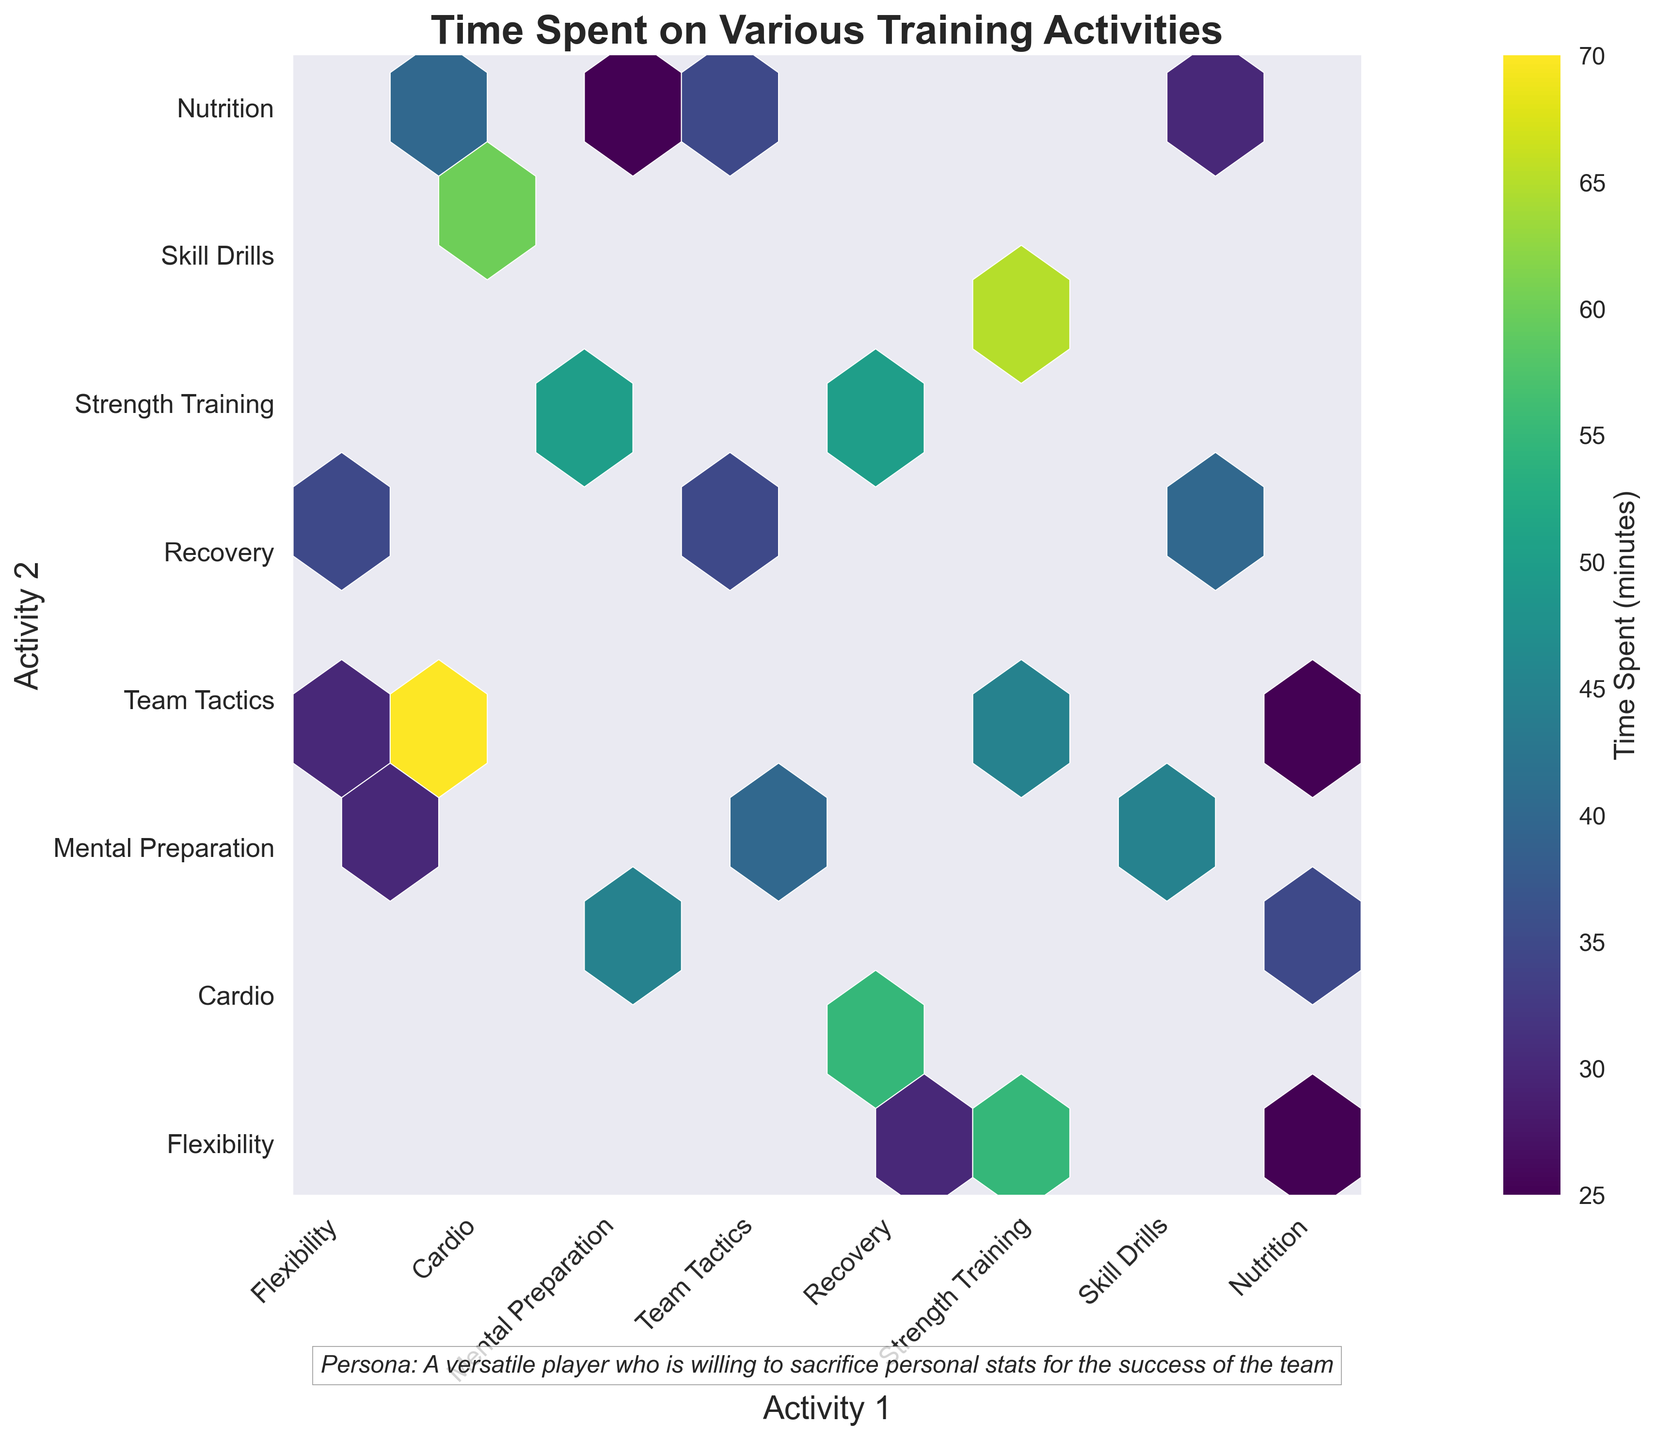what is the title of the plot? The title of the plot can be found at the top of the figure, which is a text string that generally summarizes what the plot is about. In this plot, the title is "Time Spent on Various Training Activities".
Answer: Time Spent on Various Training Activities what do the axes represent? The x-axis and y-axis labels describe what activities are being compared. The x-axis is labeled as "Activity 1” and the y-axis is labeled as “Activity 2”.
Answer: Activity 1 and Activity 2 which pair of activities shows the highest time spent together? To find which pair of activities has the highest time spent, look for the hexagon with the highest color intensity. The color bar indicates that higher values are represented by more intense colors. Identify which hexagon has the deepest color and note its corresponding activities on the x and y axis.
Answer: Cardio and Team Tactics how many unique activities are compared in the plot? Unique activities can be counted by noting the number of labels on either the x-axis or y-axis. Since both axes represent the same set of activities, count the number of unique labels. There are several labels including “Strength Training”, “Cardio”, “Flexibility”, “Skill Drills”, etc. Count these distinct labels to get the total unique activities.
Answer: 9 which two activities have the closest average time spent together, and what is that average? For each pair of activities, calculate their average time spent together, then compare these averages. First, find these average values from the color bar and then compare them to identify which pair has the value closest to other pairs. For example, if pair A has values 45, the pair B has values 40 and so on, calculate which pair has the closest values. This might require checking all related hexagons.
Answer: Recovery and Flexibility which pair of activities shows the lowest time spent together? Locate the hexagon with the lightest color intensity according to the color bar, which indicates the lowest time spent together for a pair of activities. Identify which hexagon has the palest color and note its corresponding activities on the x and y axis.
Answer: Nutrition and Flexibility do any pairs of activities have equal time spent? To determine if any pairs of activities have the same time spent, look for hexagons that share the same color intensity. Compare the hex colors with the help of the color bar to see if any pairs have matching shades. If no pairs match exactly, then none have equal time spent.
Answer: Yes what is the color of the hexagon representing the highest value on the plot? Identify the hexagon with the highest time spent value and check its color intensity. Reference the color bar to know this hexagon’s color, which represents the highest value.
Answer: Dark Purple what do the colors in the hexbin plot represent? Colors in the hexbin plot represent different ranges of time spent on various training activities. The color intensity increases with the amount of time spent together as indicated by the color bar. Lighter colors represent lower time spent, and darker colors represent higher time spent.
Answer: Time spent (minutes) 